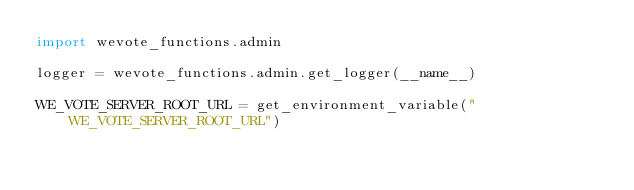<code> <loc_0><loc_0><loc_500><loc_500><_Python_>import wevote_functions.admin

logger = wevote_functions.admin.get_logger(__name__)

WE_VOTE_SERVER_ROOT_URL = get_environment_variable("WE_VOTE_SERVER_ROOT_URL")

</code> 